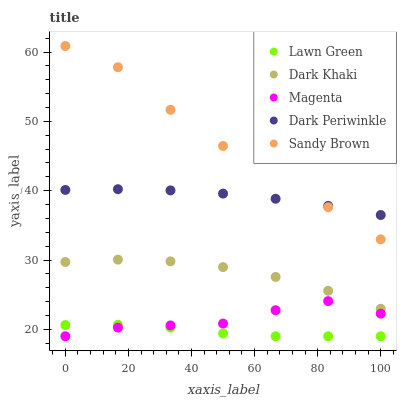Does Lawn Green have the minimum area under the curve?
Answer yes or no. Yes. Does Sandy Brown have the maximum area under the curve?
Answer yes or no. Yes. Does Magenta have the minimum area under the curve?
Answer yes or no. No. Does Magenta have the maximum area under the curve?
Answer yes or no. No. Is Dark Periwinkle the smoothest?
Answer yes or no. Yes. Is Sandy Brown the roughest?
Answer yes or no. Yes. Is Lawn Green the smoothest?
Answer yes or no. No. Is Lawn Green the roughest?
Answer yes or no. No. Does Lawn Green have the lowest value?
Answer yes or no. Yes. Does Sandy Brown have the lowest value?
Answer yes or no. No. Does Sandy Brown have the highest value?
Answer yes or no. Yes. Does Magenta have the highest value?
Answer yes or no. No. Is Lawn Green less than Dark Periwinkle?
Answer yes or no. Yes. Is Dark Khaki greater than Magenta?
Answer yes or no. Yes. Does Lawn Green intersect Magenta?
Answer yes or no. Yes. Is Lawn Green less than Magenta?
Answer yes or no. No. Is Lawn Green greater than Magenta?
Answer yes or no. No. Does Lawn Green intersect Dark Periwinkle?
Answer yes or no. No. 